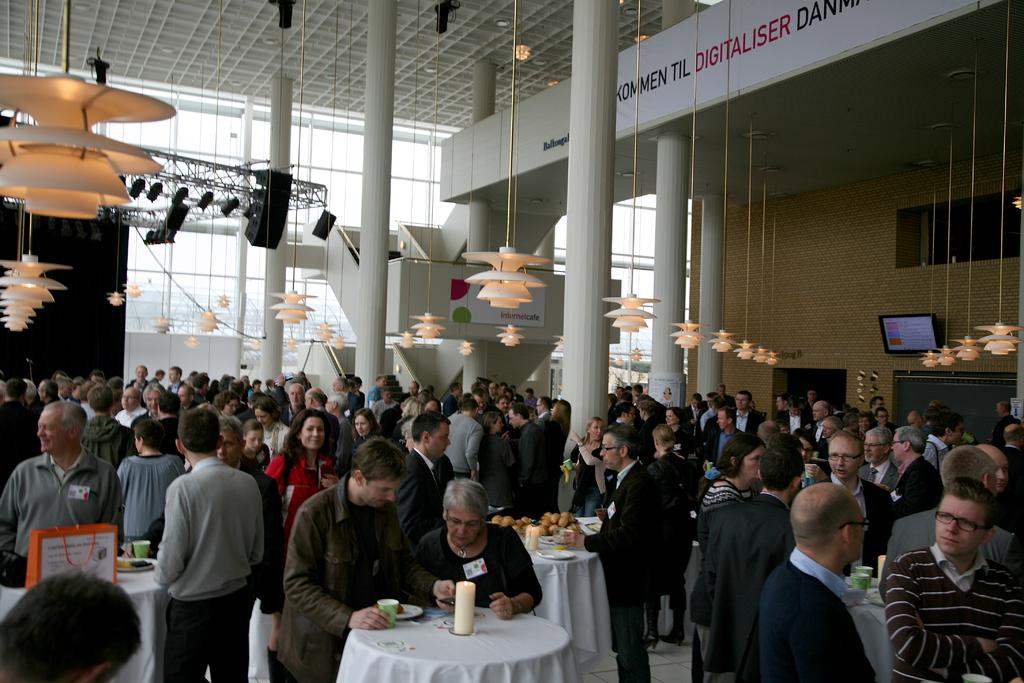What type of structure can be seen in the image? There is a wall in the image. What can be found on the wall? There is a screen in the image. What allows natural light to enter the space? There are windows in the image. What provides illumination in the image? There are lights in the image. Who is present in the image? There are people in the image. What type of furniture is visible in the image? There are tables in the image. What is placed on one of the tables? There is a candle on a table. What is placed on another table? There is a plate on a table. What is placed on yet another table? There is a glass on a table. What type of food is visible on a table? There are fruits on a table. How many cubs are playing with the people in the image? There are no cubs present in the image. What type of friend is sitting next to the person on the left side of the image? There is no friend present in the image. 